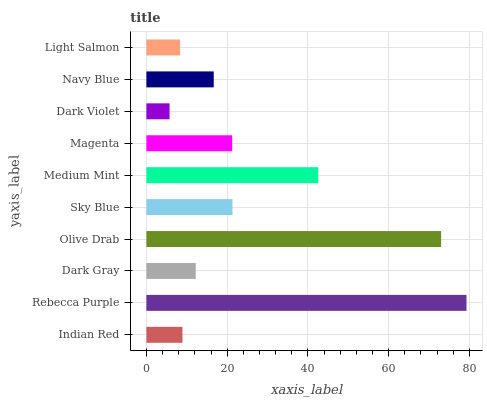Is Dark Violet the minimum?
Answer yes or no. Yes. Is Rebecca Purple the maximum?
Answer yes or no. Yes. Is Dark Gray the minimum?
Answer yes or no. No. Is Dark Gray the maximum?
Answer yes or no. No. Is Rebecca Purple greater than Dark Gray?
Answer yes or no. Yes. Is Dark Gray less than Rebecca Purple?
Answer yes or no. Yes. Is Dark Gray greater than Rebecca Purple?
Answer yes or no. No. Is Rebecca Purple less than Dark Gray?
Answer yes or no. No. Is Magenta the high median?
Answer yes or no. Yes. Is Navy Blue the low median?
Answer yes or no. Yes. Is Dark Gray the high median?
Answer yes or no. No. Is Dark Gray the low median?
Answer yes or no. No. 